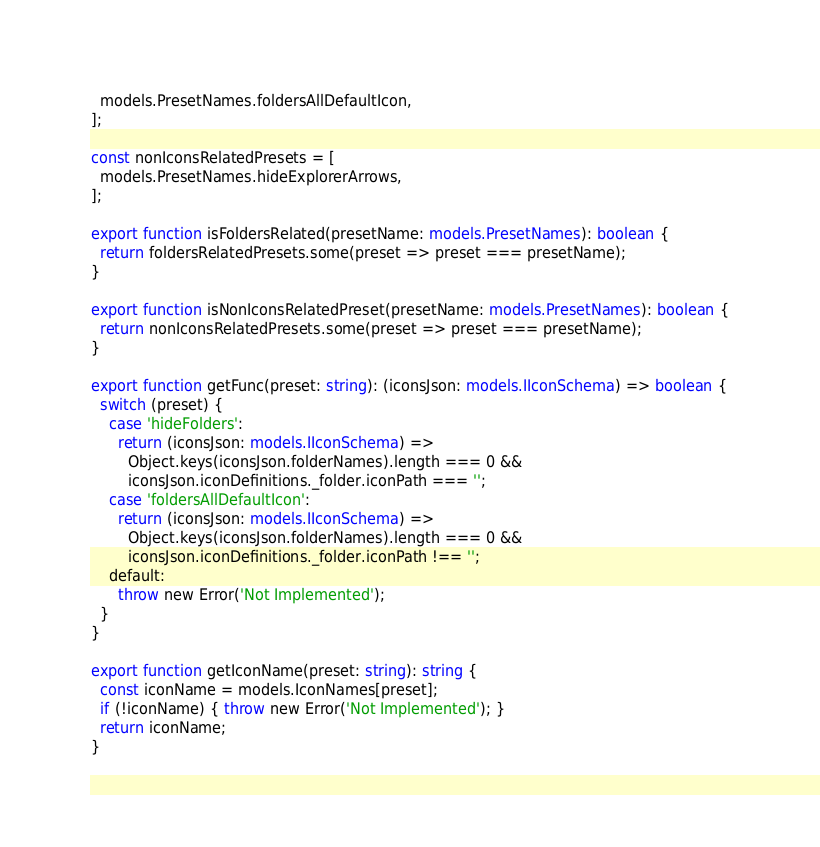Convert code to text. <code><loc_0><loc_0><loc_500><loc_500><_TypeScript_>  models.PresetNames.foldersAllDefaultIcon,
];

const nonIconsRelatedPresets = [
  models.PresetNames.hideExplorerArrows,
];

export function isFoldersRelated(presetName: models.PresetNames): boolean {
  return foldersRelatedPresets.some(preset => preset === presetName);
}

export function isNonIconsRelatedPreset(presetName: models.PresetNames): boolean {
  return nonIconsRelatedPresets.some(preset => preset === presetName);
}

export function getFunc(preset: string): (iconsJson: models.IIconSchema) => boolean {
  switch (preset) {
    case 'hideFolders':
      return (iconsJson: models.IIconSchema) =>
        Object.keys(iconsJson.folderNames).length === 0 &&
        iconsJson.iconDefinitions._folder.iconPath === '';
    case 'foldersAllDefaultIcon':
      return (iconsJson: models.IIconSchema) =>
        Object.keys(iconsJson.folderNames).length === 0 &&
        iconsJson.iconDefinitions._folder.iconPath !== '';
    default:
      throw new Error('Not Implemented');
  }
}

export function getIconName(preset: string): string {
  const iconName = models.IconNames[preset];
  if (!iconName) { throw new Error('Not Implemented'); }
  return iconName;
}
</code> 